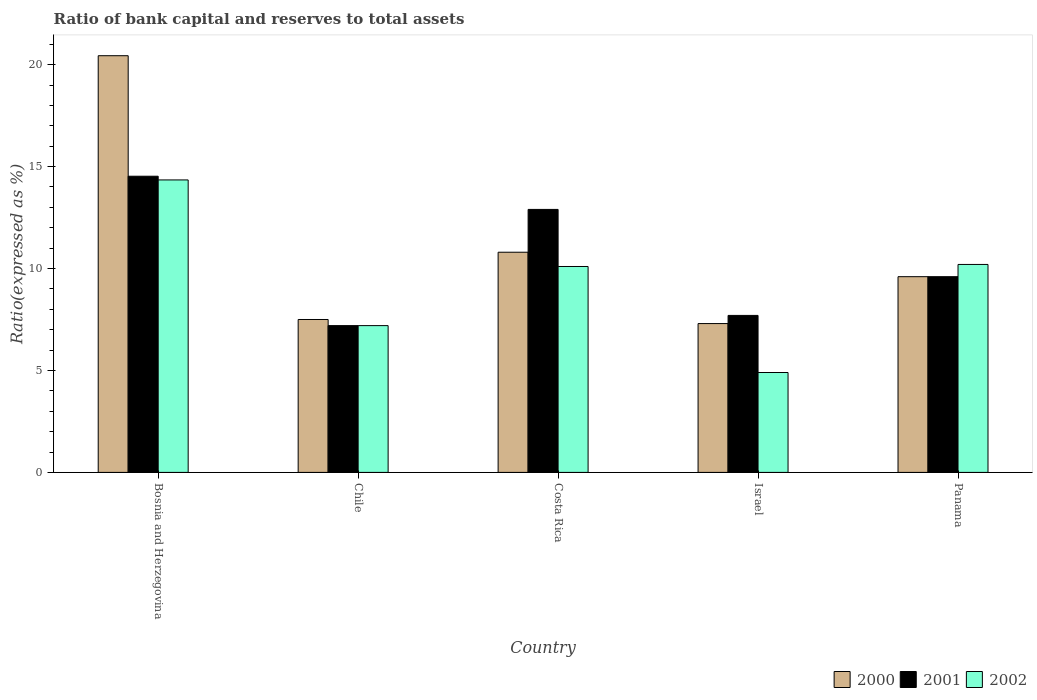How many groups of bars are there?
Offer a very short reply. 5. Are the number of bars on each tick of the X-axis equal?
Provide a short and direct response. Yes. How many bars are there on the 1st tick from the right?
Your response must be concise. 3. In how many cases, is the number of bars for a given country not equal to the number of legend labels?
Your answer should be very brief. 0. Across all countries, what is the maximum ratio of bank capital and reserves to total assets in 2000?
Offer a very short reply. 20.44. Across all countries, what is the minimum ratio of bank capital and reserves to total assets in 2002?
Your response must be concise. 4.9. In which country was the ratio of bank capital and reserves to total assets in 2002 maximum?
Your answer should be very brief. Bosnia and Herzegovina. What is the total ratio of bank capital and reserves to total assets in 2001 in the graph?
Make the answer very short. 51.93. What is the difference between the ratio of bank capital and reserves to total assets in 2002 in Panama and the ratio of bank capital and reserves to total assets in 2000 in Bosnia and Herzegovina?
Provide a succinct answer. -10.24. What is the average ratio of bank capital and reserves to total assets in 2000 per country?
Ensure brevity in your answer.  11.13. What is the difference between the ratio of bank capital and reserves to total assets of/in 2000 and ratio of bank capital and reserves to total assets of/in 2001 in Bosnia and Herzegovina?
Give a very brief answer. 5.91. In how many countries, is the ratio of bank capital and reserves to total assets in 2002 greater than 5 %?
Make the answer very short. 4. What is the ratio of the ratio of bank capital and reserves to total assets in 2000 in Chile to that in Panama?
Keep it short and to the point. 0.78. Is the ratio of bank capital and reserves to total assets in 2001 in Bosnia and Herzegovina less than that in Costa Rica?
Give a very brief answer. No. What is the difference between the highest and the second highest ratio of bank capital and reserves to total assets in 2000?
Your answer should be very brief. -1.2. What is the difference between the highest and the lowest ratio of bank capital and reserves to total assets in 2000?
Give a very brief answer. 13.14. What does the 2nd bar from the right in Costa Rica represents?
Make the answer very short. 2001. Is it the case that in every country, the sum of the ratio of bank capital and reserves to total assets in 2002 and ratio of bank capital and reserves to total assets in 2000 is greater than the ratio of bank capital and reserves to total assets in 2001?
Keep it short and to the point. Yes. Are all the bars in the graph horizontal?
Offer a terse response. No. What is the difference between two consecutive major ticks on the Y-axis?
Provide a succinct answer. 5. Are the values on the major ticks of Y-axis written in scientific E-notation?
Your answer should be compact. No. Where does the legend appear in the graph?
Make the answer very short. Bottom right. How many legend labels are there?
Provide a short and direct response. 3. What is the title of the graph?
Provide a succinct answer. Ratio of bank capital and reserves to total assets. What is the label or title of the X-axis?
Ensure brevity in your answer.  Country. What is the label or title of the Y-axis?
Your answer should be compact. Ratio(expressed as %). What is the Ratio(expressed as %) of 2000 in Bosnia and Herzegovina?
Ensure brevity in your answer.  20.44. What is the Ratio(expressed as %) in 2001 in Bosnia and Herzegovina?
Your response must be concise. 14.53. What is the Ratio(expressed as %) in 2002 in Bosnia and Herzegovina?
Your answer should be very brief. 14.35. What is the Ratio(expressed as %) in 2002 in Chile?
Keep it short and to the point. 7.2. What is the Ratio(expressed as %) in 2000 in Costa Rica?
Offer a terse response. 10.8. What is the Ratio(expressed as %) of 2001 in Costa Rica?
Provide a short and direct response. 12.9. What is the Ratio(expressed as %) in 2002 in Costa Rica?
Provide a short and direct response. 10.1. What is the Ratio(expressed as %) in 2001 in Israel?
Offer a very short reply. 7.7. What is the Ratio(expressed as %) in 2000 in Panama?
Make the answer very short. 9.6. What is the Ratio(expressed as %) of 2002 in Panama?
Provide a succinct answer. 10.2. Across all countries, what is the maximum Ratio(expressed as %) of 2000?
Give a very brief answer. 20.44. Across all countries, what is the maximum Ratio(expressed as %) in 2001?
Offer a very short reply. 14.53. Across all countries, what is the maximum Ratio(expressed as %) of 2002?
Your answer should be compact. 14.35. Across all countries, what is the minimum Ratio(expressed as %) in 2000?
Give a very brief answer. 7.3. Across all countries, what is the minimum Ratio(expressed as %) of 2001?
Make the answer very short. 7.2. Across all countries, what is the minimum Ratio(expressed as %) of 2002?
Provide a succinct answer. 4.9. What is the total Ratio(expressed as %) in 2000 in the graph?
Offer a very short reply. 55.64. What is the total Ratio(expressed as %) in 2001 in the graph?
Ensure brevity in your answer.  51.93. What is the total Ratio(expressed as %) in 2002 in the graph?
Your answer should be very brief. 46.75. What is the difference between the Ratio(expressed as %) of 2000 in Bosnia and Herzegovina and that in Chile?
Give a very brief answer. 12.94. What is the difference between the Ratio(expressed as %) in 2001 in Bosnia and Herzegovina and that in Chile?
Your answer should be compact. 7.33. What is the difference between the Ratio(expressed as %) in 2002 in Bosnia and Herzegovina and that in Chile?
Make the answer very short. 7.15. What is the difference between the Ratio(expressed as %) in 2000 in Bosnia and Herzegovina and that in Costa Rica?
Your answer should be very brief. 9.64. What is the difference between the Ratio(expressed as %) of 2001 in Bosnia and Herzegovina and that in Costa Rica?
Make the answer very short. 1.63. What is the difference between the Ratio(expressed as %) of 2002 in Bosnia and Herzegovina and that in Costa Rica?
Your answer should be compact. 4.25. What is the difference between the Ratio(expressed as %) of 2000 in Bosnia and Herzegovina and that in Israel?
Provide a short and direct response. 13.14. What is the difference between the Ratio(expressed as %) of 2001 in Bosnia and Herzegovina and that in Israel?
Ensure brevity in your answer.  6.83. What is the difference between the Ratio(expressed as %) in 2002 in Bosnia and Herzegovina and that in Israel?
Your response must be concise. 9.45. What is the difference between the Ratio(expressed as %) in 2000 in Bosnia and Herzegovina and that in Panama?
Make the answer very short. 10.84. What is the difference between the Ratio(expressed as %) of 2001 in Bosnia and Herzegovina and that in Panama?
Offer a very short reply. 4.93. What is the difference between the Ratio(expressed as %) in 2002 in Bosnia and Herzegovina and that in Panama?
Your response must be concise. 4.15. What is the difference between the Ratio(expressed as %) of 2000 in Chile and that in Israel?
Your answer should be compact. 0.2. What is the difference between the Ratio(expressed as %) of 2001 in Chile and that in Israel?
Your answer should be very brief. -0.5. What is the difference between the Ratio(expressed as %) in 2002 in Chile and that in Israel?
Provide a succinct answer. 2.3. What is the difference between the Ratio(expressed as %) of 2000 in Chile and that in Panama?
Keep it short and to the point. -2.1. What is the difference between the Ratio(expressed as %) in 2002 in Chile and that in Panama?
Offer a very short reply. -3. What is the difference between the Ratio(expressed as %) in 2001 in Costa Rica and that in Israel?
Offer a terse response. 5.2. What is the difference between the Ratio(expressed as %) in 2002 in Costa Rica and that in Israel?
Offer a terse response. 5.2. What is the difference between the Ratio(expressed as %) in 2002 in Costa Rica and that in Panama?
Keep it short and to the point. -0.1. What is the difference between the Ratio(expressed as %) of 2002 in Israel and that in Panama?
Give a very brief answer. -5.3. What is the difference between the Ratio(expressed as %) of 2000 in Bosnia and Herzegovina and the Ratio(expressed as %) of 2001 in Chile?
Offer a very short reply. 13.24. What is the difference between the Ratio(expressed as %) in 2000 in Bosnia and Herzegovina and the Ratio(expressed as %) in 2002 in Chile?
Your response must be concise. 13.24. What is the difference between the Ratio(expressed as %) in 2001 in Bosnia and Herzegovina and the Ratio(expressed as %) in 2002 in Chile?
Give a very brief answer. 7.33. What is the difference between the Ratio(expressed as %) in 2000 in Bosnia and Herzegovina and the Ratio(expressed as %) in 2001 in Costa Rica?
Keep it short and to the point. 7.54. What is the difference between the Ratio(expressed as %) of 2000 in Bosnia and Herzegovina and the Ratio(expressed as %) of 2002 in Costa Rica?
Keep it short and to the point. 10.34. What is the difference between the Ratio(expressed as %) in 2001 in Bosnia and Herzegovina and the Ratio(expressed as %) in 2002 in Costa Rica?
Make the answer very short. 4.43. What is the difference between the Ratio(expressed as %) of 2000 in Bosnia and Herzegovina and the Ratio(expressed as %) of 2001 in Israel?
Keep it short and to the point. 12.74. What is the difference between the Ratio(expressed as %) in 2000 in Bosnia and Herzegovina and the Ratio(expressed as %) in 2002 in Israel?
Your response must be concise. 15.54. What is the difference between the Ratio(expressed as %) in 2001 in Bosnia and Herzegovina and the Ratio(expressed as %) in 2002 in Israel?
Provide a succinct answer. 9.63. What is the difference between the Ratio(expressed as %) in 2000 in Bosnia and Herzegovina and the Ratio(expressed as %) in 2001 in Panama?
Ensure brevity in your answer.  10.84. What is the difference between the Ratio(expressed as %) of 2000 in Bosnia and Herzegovina and the Ratio(expressed as %) of 2002 in Panama?
Provide a short and direct response. 10.24. What is the difference between the Ratio(expressed as %) in 2001 in Bosnia and Herzegovina and the Ratio(expressed as %) in 2002 in Panama?
Offer a very short reply. 4.33. What is the difference between the Ratio(expressed as %) in 2000 in Chile and the Ratio(expressed as %) in 2002 in Costa Rica?
Offer a terse response. -2.6. What is the difference between the Ratio(expressed as %) of 2001 in Chile and the Ratio(expressed as %) of 2002 in Costa Rica?
Keep it short and to the point. -2.9. What is the difference between the Ratio(expressed as %) in 2000 in Chile and the Ratio(expressed as %) in 2001 in Israel?
Keep it short and to the point. -0.2. What is the difference between the Ratio(expressed as %) in 2000 in Chile and the Ratio(expressed as %) in 2002 in Israel?
Give a very brief answer. 2.6. What is the difference between the Ratio(expressed as %) of 2001 in Chile and the Ratio(expressed as %) of 2002 in Israel?
Provide a short and direct response. 2.3. What is the difference between the Ratio(expressed as %) of 2000 in Costa Rica and the Ratio(expressed as %) of 2001 in Israel?
Offer a terse response. 3.1. What is the difference between the Ratio(expressed as %) of 2000 in Costa Rica and the Ratio(expressed as %) of 2002 in Israel?
Offer a terse response. 5.9. What is the difference between the Ratio(expressed as %) of 2001 in Costa Rica and the Ratio(expressed as %) of 2002 in Israel?
Ensure brevity in your answer.  8. What is the difference between the Ratio(expressed as %) of 2001 in Costa Rica and the Ratio(expressed as %) of 2002 in Panama?
Give a very brief answer. 2.7. What is the difference between the Ratio(expressed as %) of 2000 in Israel and the Ratio(expressed as %) of 2001 in Panama?
Provide a succinct answer. -2.3. What is the average Ratio(expressed as %) of 2000 per country?
Your answer should be very brief. 11.13. What is the average Ratio(expressed as %) in 2001 per country?
Make the answer very short. 10.39. What is the average Ratio(expressed as %) of 2002 per country?
Keep it short and to the point. 9.35. What is the difference between the Ratio(expressed as %) of 2000 and Ratio(expressed as %) of 2001 in Bosnia and Herzegovina?
Offer a terse response. 5.91. What is the difference between the Ratio(expressed as %) in 2000 and Ratio(expressed as %) in 2002 in Bosnia and Herzegovina?
Your answer should be compact. 6.09. What is the difference between the Ratio(expressed as %) of 2001 and Ratio(expressed as %) of 2002 in Bosnia and Herzegovina?
Keep it short and to the point. 0.18. What is the difference between the Ratio(expressed as %) in 2000 and Ratio(expressed as %) in 2001 in Chile?
Provide a short and direct response. 0.3. What is the difference between the Ratio(expressed as %) of 2000 and Ratio(expressed as %) of 2002 in Chile?
Your answer should be compact. 0.3. What is the difference between the Ratio(expressed as %) in 2000 and Ratio(expressed as %) in 2001 in Costa Rica?
Your response must be concise. -2.1. What is the difference between the Ratio(expressed as %) in 2000 and Ratio(expressed as %) in 2002 in Costa Rica?
Ensure brevity in your answer.  0.7. What is the difference between the Ratio(expressed as %) of 2001 and Ratio(expressed as %) of 2002 in Israel?
Your answer should be very brief. 2.8. What is the difference between the Ratio(expressed as %) of 2000 and Ratio(expressed as %) of 2001 in Panama?
Ensure brevity in your answer.  0. What is the difference between the Ratio(expressed as %) in 2000 and Ratio(expressed as %) in 2002 in Panama?
Your answer should be very brief. -0.6. What is the ratio of the Ratio(expressed as %) of 2000 in Bosnia and Herzegovina to that in Chile?
Give a very brief answer. 2.73. What is the ratio of the Ratio(expressed as %) of 2001 in Bosnia and Herzegovina to that in Chile?
Offer a very short reply. 2.02. What is the ratio of the Ratio(expressed as %) in 2002 in Bosnia and Herzegovina to that in Chile?
Give a very brief answer. 1.99. What is the ratio of the Ratio(expressed as %) in 2000 in Bosnia and Herzegovina to that in Costa Rica?
Ensure brevity in your answer.  1.89. What is the ratio of the Ratio(expressed as %) of 2001 in Bosnia and Herzegovina to that in Costa Rica?
Ensure brevity in your answer.  1.13. What is the ratio of the Ratio(expressed as %) of 2002 in Bosnia and Herzegovina to that in Costa Rica?
Give a very brief answer. 1.42. What is the ratio of the Ratio(expressed as %) of 2000 in Bosnia and Herzegovina to that in Israel?
Your answer should be compact. 2.8. What is the ratio of the Ratio(expressed as %) in 2001 in Bosnia and Herzegovina to that in Israel?
Make the answer very short. 1.89. What is the ratio of the Ratio(expressed as %) in 2002 in Bosnia and Herzegovina to that in Israel?
Make the answer very short. 2.93. What is the ratio of the Ratio(expressed as %) of 2000 in Bosnia and Herzegovina to that in Panama?
Ensure brevity in your answer.  2.13. What is the ratio of the Ratio(expressed as %) in 2001 in Bosnia and Herzegovina to that in Panama?
Make the answer very short. 1.51. What is the ratio of the Ratio(expressed as %) of 2002 in Bosnia and Herzegovina to that in Panama?
Provide a short and direct response. 1.41. What is the ratio of the Ratio(expressed as %) in 2000 in Chile to that in Costa Rica?
Your answer should be compact. 0.69. What is the ratio of the Ratio(expressed as %) of 2001 in Chile to that in Costa Rica?
Make the answer very short. 0.56. What is the ratio of the Ratio(expressed as %) in 2002 in Chile to that in Costa Rica?
Your answer should be very brief. 0.71. What is the ratio of the Ratio(expressed as %) of 2000 in Chile to that in Israel?
Give a very brief answer. 1.03. What is the ratio of the Ratio(expressed as %) of 2001 in Chile to that in Israel?
Your answer should be very brief. 0.94. What is the ratio of the Ratio(expressed as %) of 2002 in Chile to that in Israel?
Your response must be concise. 1.47. What is the ratio of the Ratio(expressed as %) of 2000 in Chile to that in Panama?
Your answer should be very brief. 0.78. What is the ratio of the Ratio(expressed as %) of 2001 in Chile to that in Panama?
Make the answer very short. 0.75. What is the ratio of the Ratio(expressed as %) of 2002 in Chile to that in Panama?
Offer a very short reply. 0.71. What is the ratio of the Ratio(expressed as %) of 2000 in Costa Rica to that in Israel?
Provide a short and direct response. 1.48. What is the ratio of the Ratio(expressed as %) of 2001 in Costa Rica to that in Israel?
Your response must be concise. 1.68. What is the ratio of the Ratio(expressed as %) of 2002 in Costa Rica to that in Israel?
Provide a succinct answer. 2.06. What is the ratio of the Ratio(expressed as %) of 2000 in Costa Rica to that in Panama?
Make the answer very short. 1.12. What is the ratio of the Ratio(expressed as %) in 2001 in Costa Rica to that in Panama?
Ensure brevity in your answer.  1.34. What is the ratio of the Ratio(expressed as %) of 2002 in Costa Rica to that in Panama?
Your answer should be very brief. 0.99. What is the ratio of the Ratio(expressed as %) in 2000 in Israel to that in Panama?
Your response must be concise. 0.76. What is the ratio of the Ratio(expressed as %) in 2001 in Israel to that in Panama?
Keep it short and to the point. 0.8. What is the ratio of the Ratio(expressed as %) of 2002 in Israel to that in Panama?
Your answer should be very brief. 0.48. What is the difference between the highest and the second highest Ratio(expressed as %) in 2000?
Offer a terse response. 9.64. What is the difference between the highest and the second highest Ratio(expressed as %) in 2001?
Your response must be concise. 1.63. What is the difference between the highest and the second highest Ratio(expressed as %) of 2002?
Ensure brevity in your answer.  4.15. What is the difference between the highest and the lowest Ratio(expressed as %) of 2000?
Offer a very short reply. 13.14. What is the difference between the highest and the lowest Ratio(expressed as %) of 2001?
Your response must be concise. 7.33. What is the difference between the highest and the lowest Ratio(expressed as %) in 2002?
Keep it short and to the point. 9.45. 